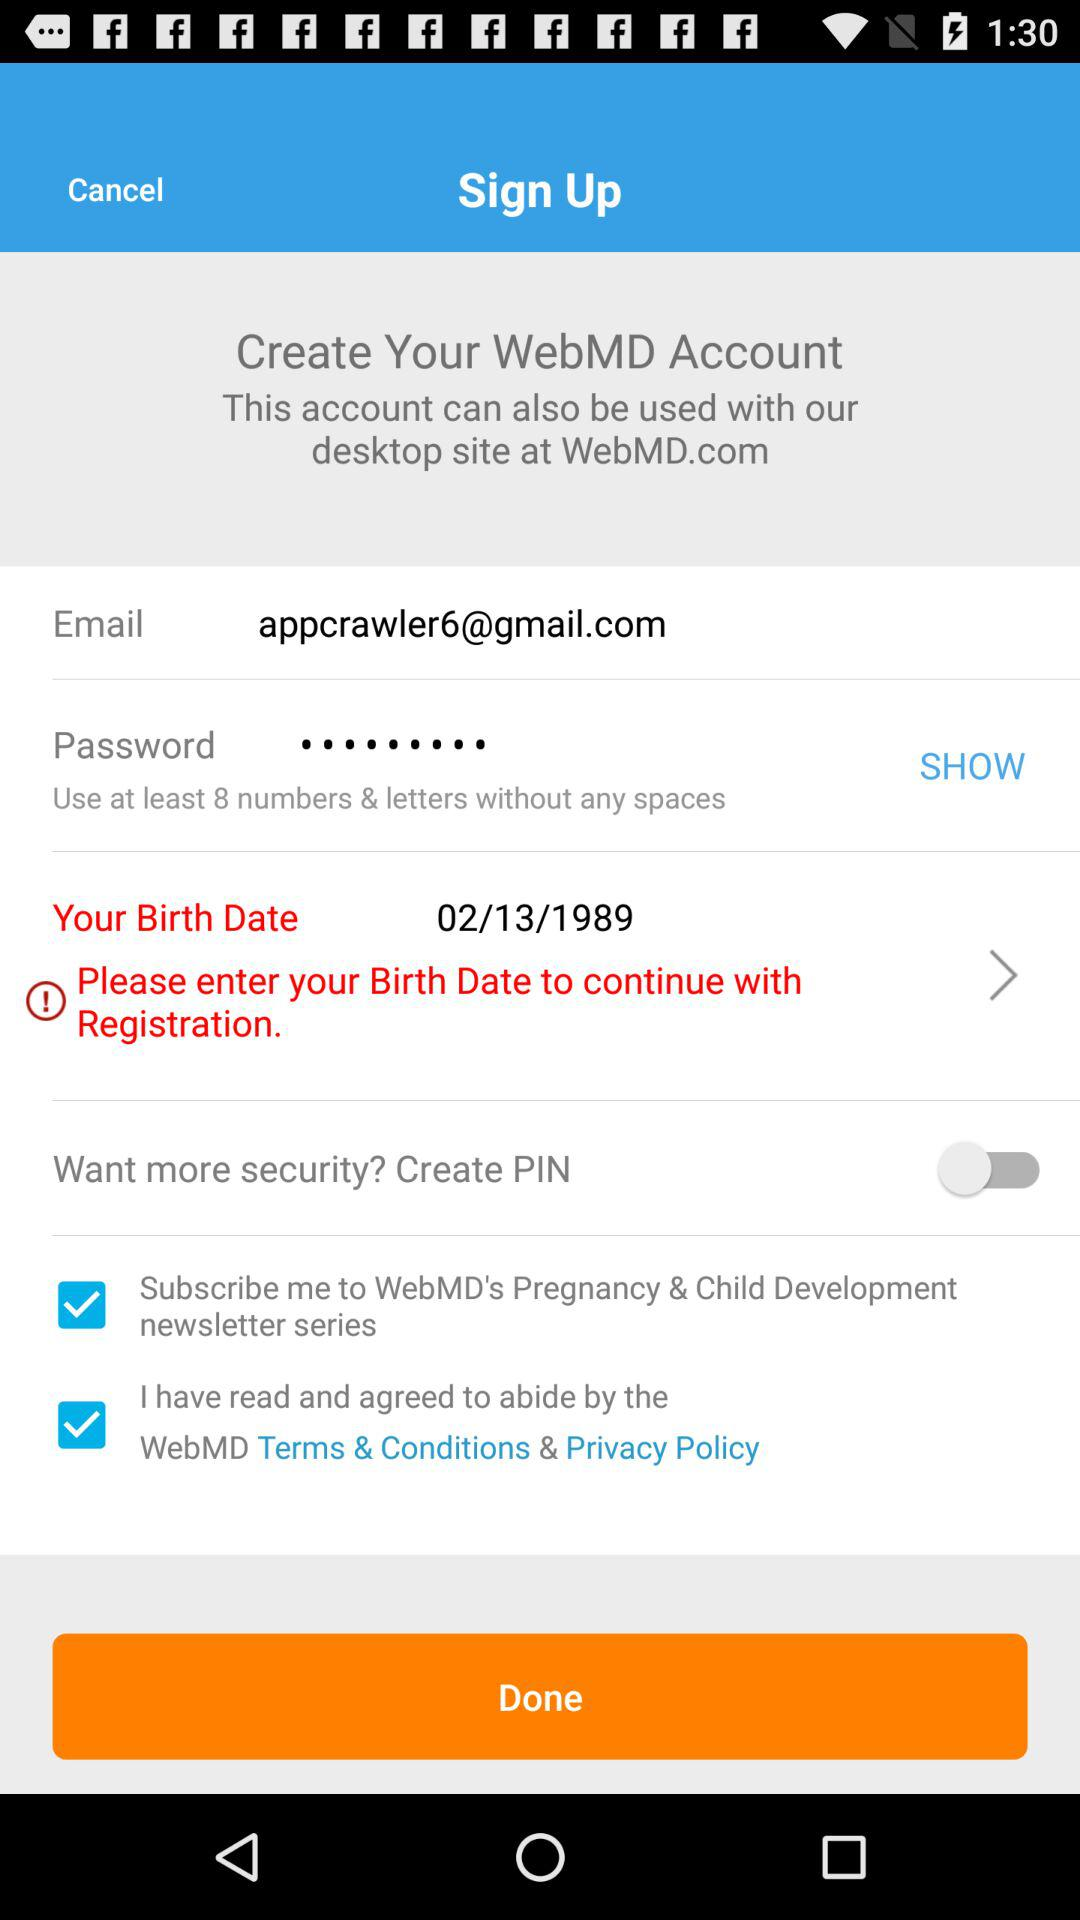What is the date of birth? The date of birth is February 13, 1989. 